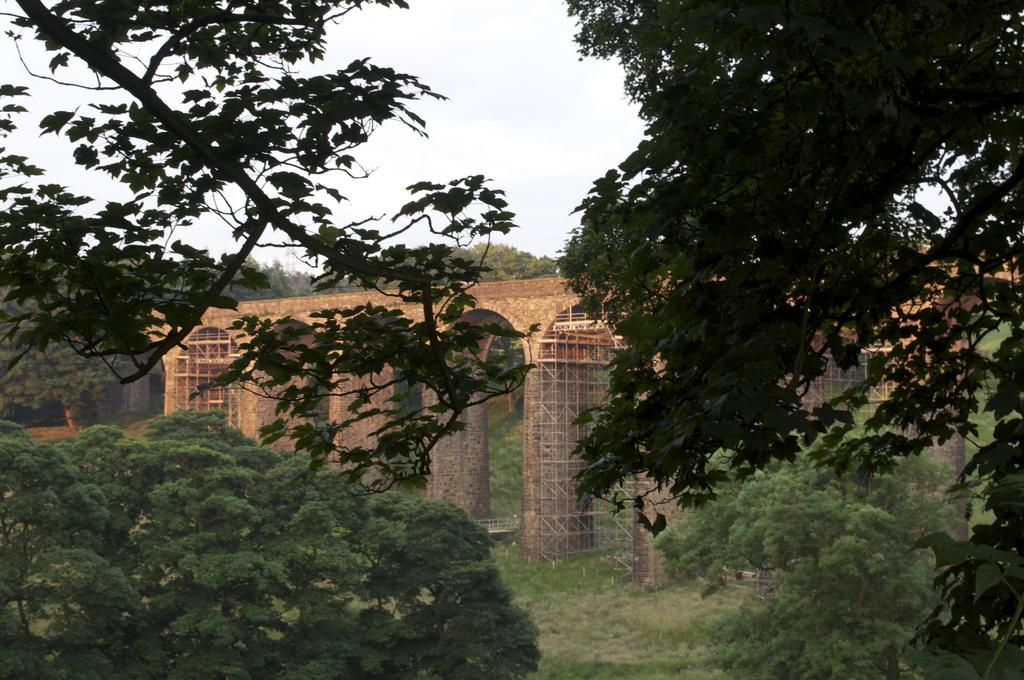What type of natural elements can be seen in the image? There are trees in the image. What man-made structure is present in the image? There is a bridge in the image. What is the color of the bridge? The bridge is brown in color. What can be seen in the background of the image? There is a sky visible in the background of the image. Can you tell me how many times the trees are playing in harmony in the image? There is no indication of trees playing in harmony in the image, as trees are natural elements and do not engage in musical activities. 